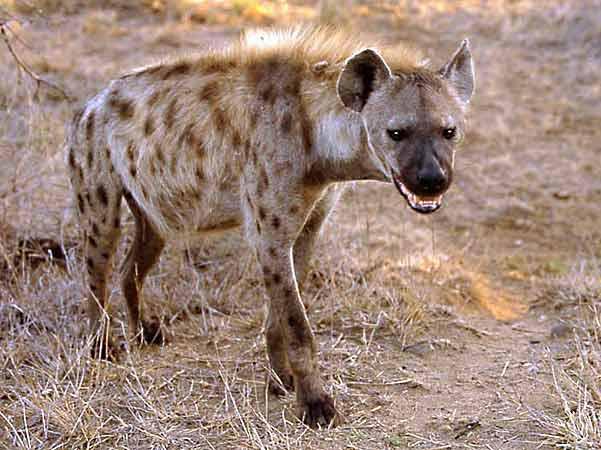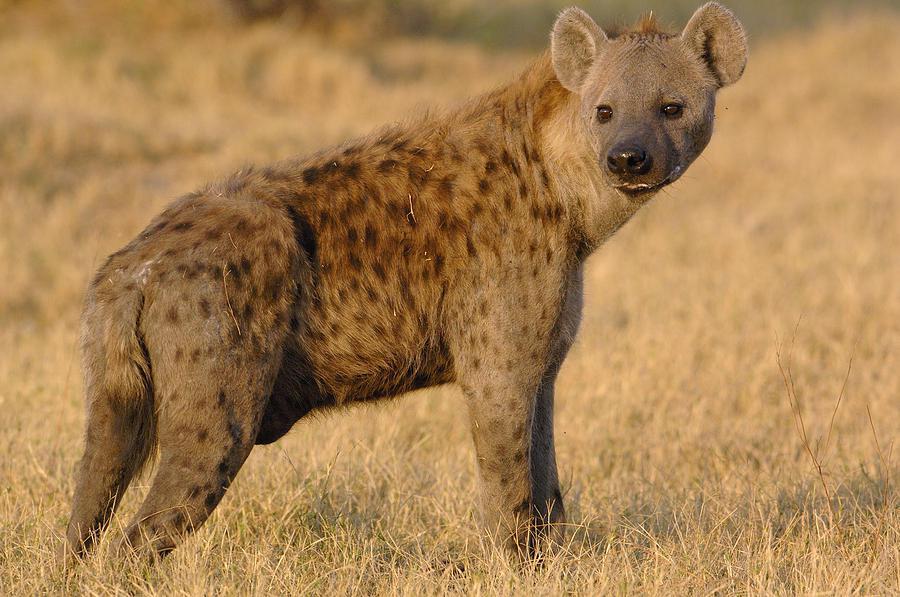The first image is the image on the left, the second image is the image on the right. Given the left and right images, does the statement "One of the images contains a hyena eating a dead animal." hold true? Answer yes or no. No. 